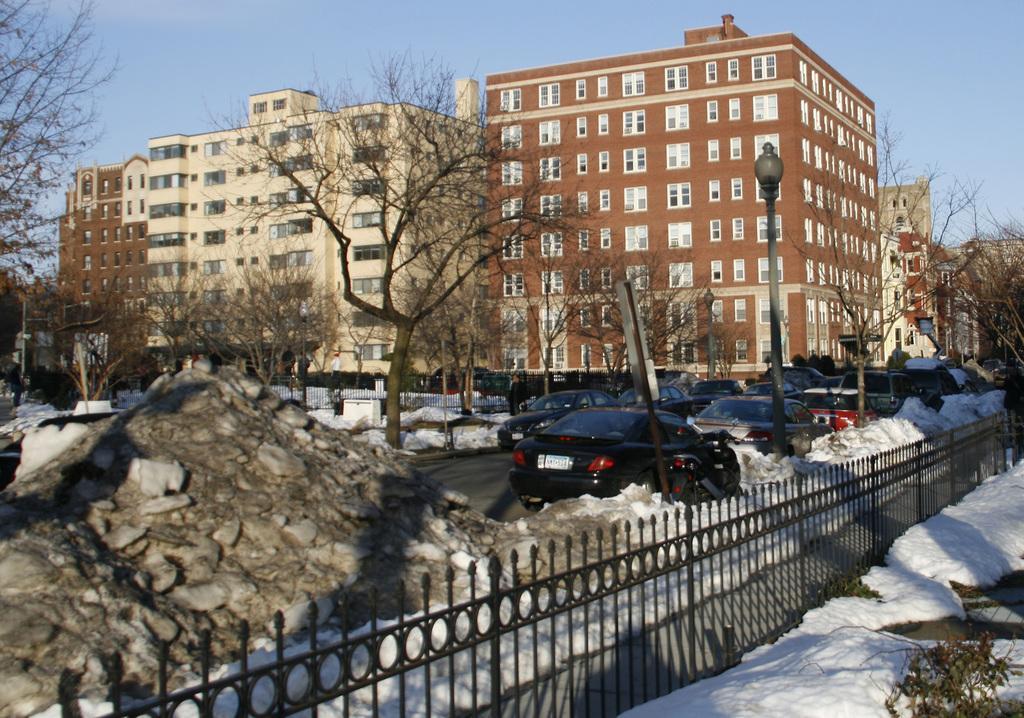Could you give a brief overview of what you see in this image? Here we can see vehicles, snow and lights on poles and we can see trees. Background we can see buildings and sky. 